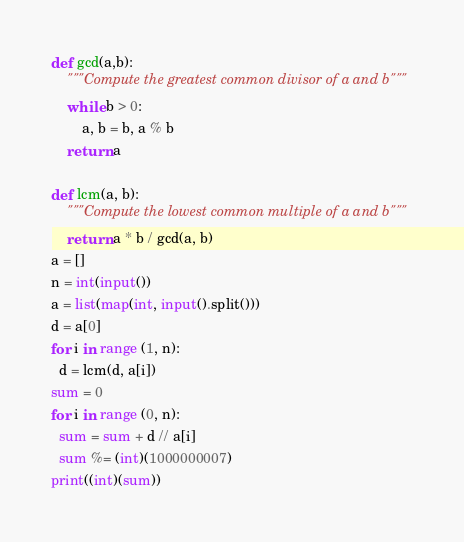<code> <loc_0><loc_0><loc_500><loc_500><_Python_>def gcd(a,b):
    """Compute the greatest common divisor of a and b"""
    while b > 0:
        a, b = b, a % b
    return a
    
def lcm(a, b):
    """Compute the lowest common multiple of a and b"""
    return a * b / gcd(a, b)
a = []
n = int(input())
a = list(map(int, input().split()))
d = a[0]
for i in range (1, n):
  d = lcm(d, a[i])
sum = 0
for i in range (0, n):
  sum = sum + d // a[i]
  sum %= (int)(1000000007)
print((int)(sum))</code> 